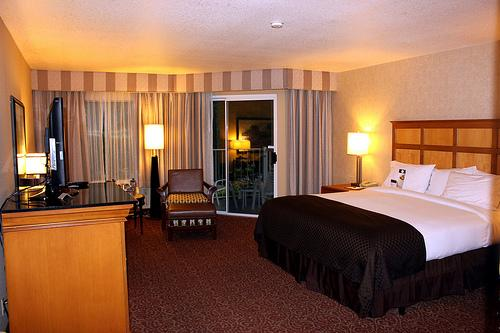What material is the carpet made of in the room and what color is it? The carpet is made of a brown material, likely synthetic fibers or wool. What object is on the dresser and what is its purpose? There is a remote control on the dresser, used for operating the television or other electronic devices. What is the type and color of the chair found near the window? The chair near the window is red and white and appears to be a side chair made of leather. How many glass doors are there in the image and where do they lead to? There is one glass door in the image that leads out to a patio. Count the number of lamps in the image and describe their placement. There are four lamps in the image: a table lamp with a shade, a floor lamp with a shade, a lamp on a desk, and a lamp next to a window. How many bed pillows are there in the image and what is their color? There are four white bed pillows in the image. Identify the color and material of the headboard in the image. The headboard is made of light and dark wood and is brown in color. In terms of color and pattern, describe the valance over the door and window. The valance over the door and window is long, striped, and has a mix of different colors. Explain the appearance of the blanket found at the bottom of the bed. The blanket at the bottom of the bed is brown in color and spread across the width of the bed. 